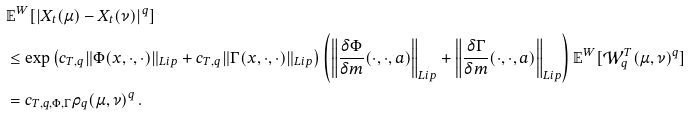<formula> <loc_0><loc_0><loc_500><loc_500>& \mathbb { E } ^ { W } [ | X _ { t } ( \mu ) - X _ { t } ( \nu ) | ^ { q } ] \\ & \leq \exp \left ( c _ { T , q } \| \Phi ( x , \cdot , \cdot ) \| _ { L i p } + c _ { T , q } \| \Gamma ( x , \cdot , \cdot ) \| _ { L i p } \right ) \left ( \left \| \frac { \delta \Phi } { \delta m } ( \cdot , \cdot , a ) \right \| _ { L i p } + \left \| \frac { \delta \Gamma } { \delta m } ( \cdot , \cdot , a ) \right \| _ { L i p } \right ) \mathbb { E } ^ { W } [ \mathcal { W } _ { q } ^ { T } ( \mu , \nu ) ^ { q } ] \\ & = c _ { T , q , \Phi , \Gamma } \rho _ { q } ( \mu , \nu ) ^ { q } \, .</formula> 